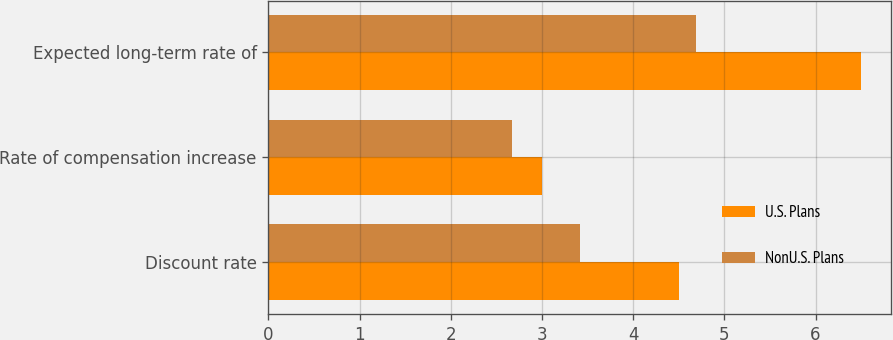Convert chart to OTSL. <chart><loc_0><loc_0><loc_500><loc_500><stacked_bar_chart><ecel><fcel>Discount rate<fcel>Rate of compensation increase<fcel>Expected long-term rate of<nl><fcel>U.S. Plans<fcel>4.5<fcel>3<fcel>6.5<nl><fcel>NonU.S. Plans<fcel>3.42<fcel>2.67<fcel>4.69<nl></chart> 